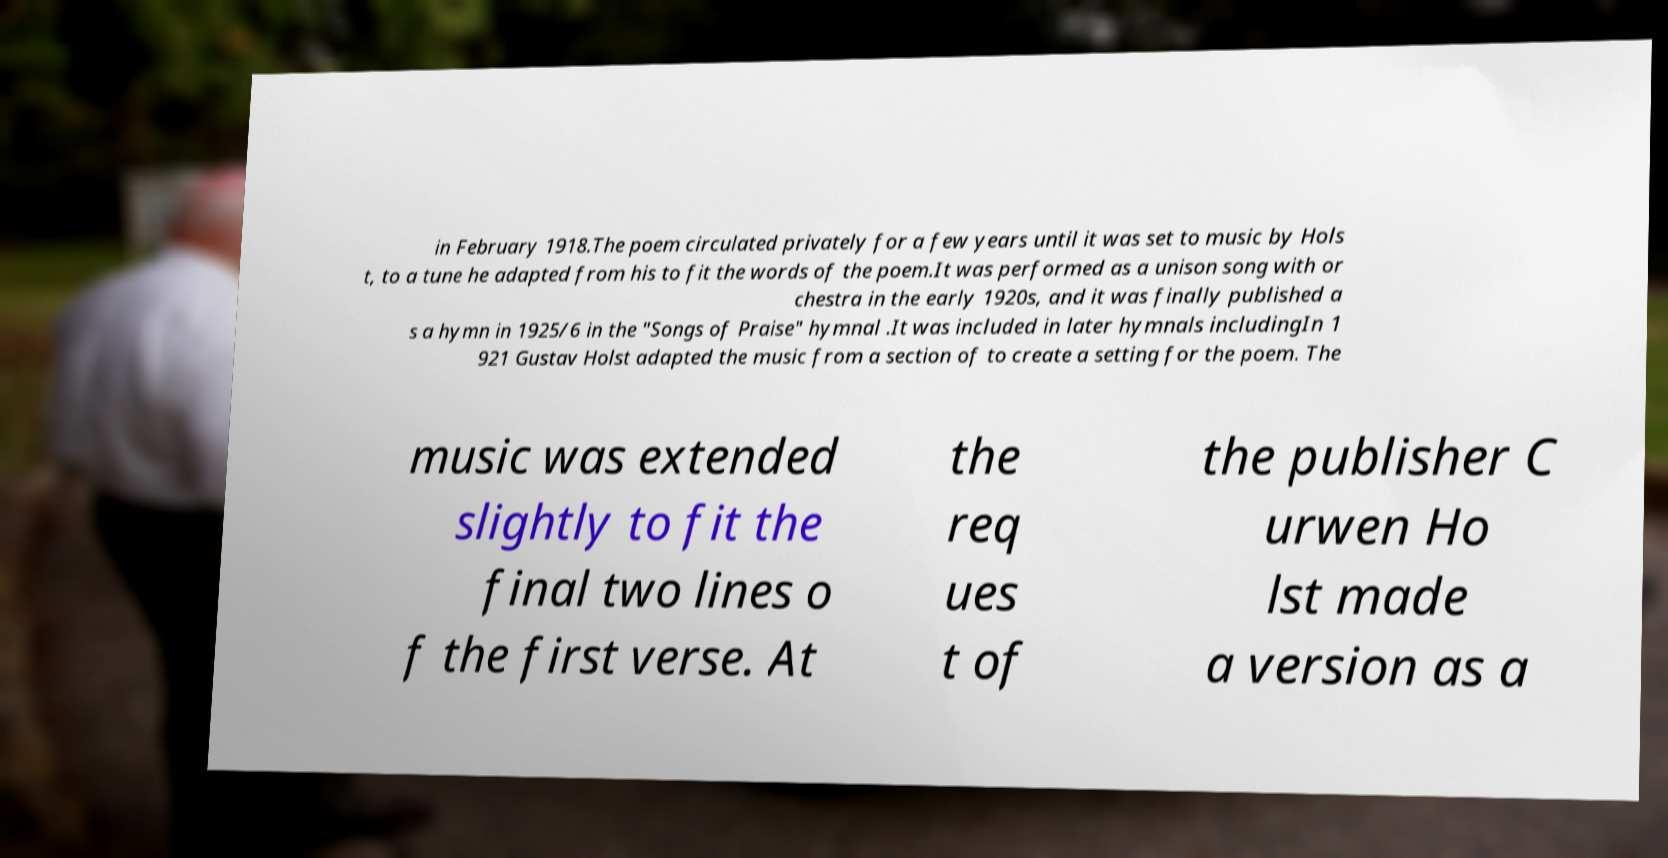Can you accurately transcribe the text from the provided image for me? in February 1918.The poem circulated privately for a few years until it was set to music by Hols t, to a tune he adapted from his to fit the words of the poem.It was performed as a unison song with or chestra in the early 1920s, and it was finally published a s a hymn in 1925/6 in the "Songs of Praise" hymnal .It was included in later hymnals includingIn 1 921 Gustav Holst adapted the music from a section of to create a setting for the poem. The music was extended slightly to fit the final two lines o f the first verse. At the req ues t of the publisher C urwen Ho lst made a version as a 